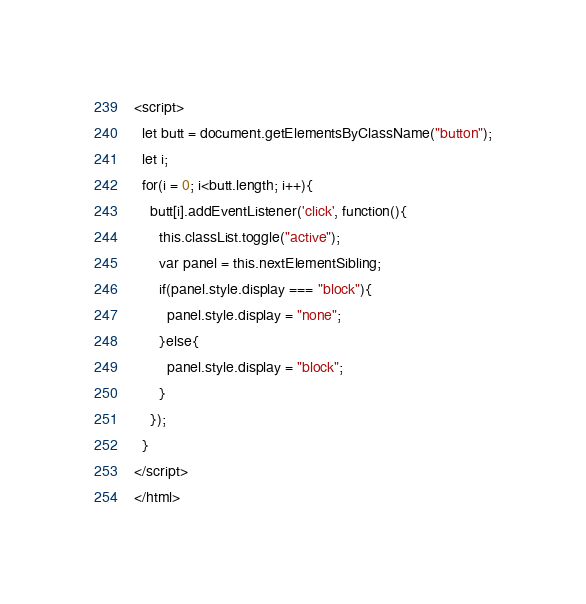<code> <loc_0><loc_0><loc_500><loc_500><_HTML_><script>
  let butt = document.getElementsByClassName("button");
  let i;
  for(i = 0; i<butt.length; i++){
    butt[i].addEventListener('click', function(){
      this.classList.toggle("active");
      var panel = this.nextElementSibling;
      if(panel.style.display === "block"){
        panel.style.display = "none";
      }else{
        panel.style.display = "block";
      }
    });
  }
</script>
</html></code> 